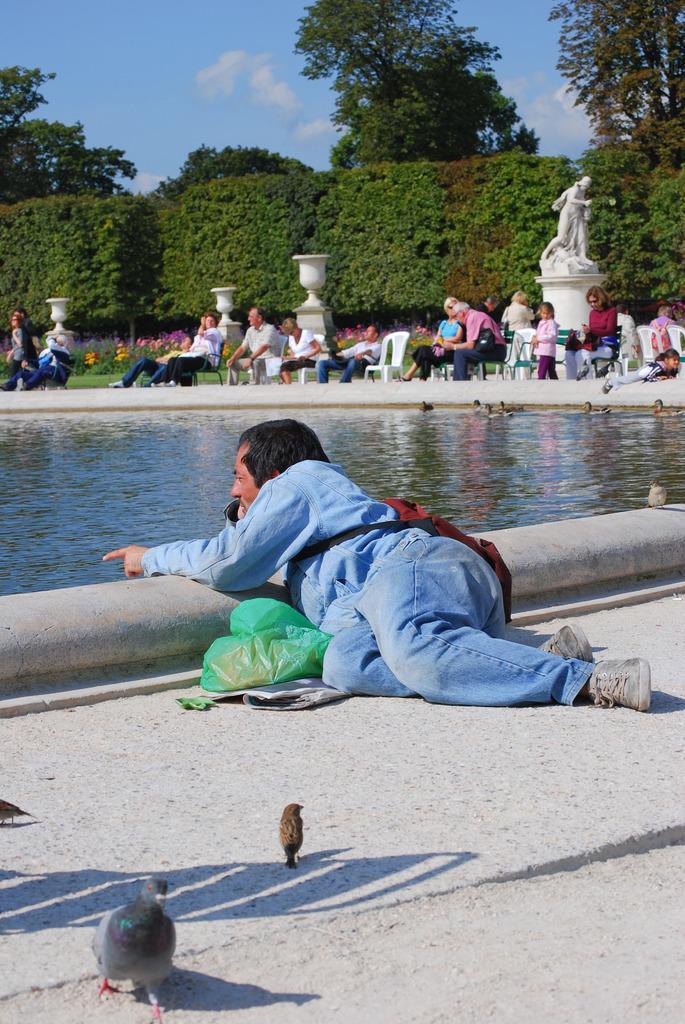Can you describe this image briefly? In this image we can see a person lying on the ground. Near to him there is a packet. Also there are few birds on the ground. In the back there is water. There are many people sitting. There is a statue on a pedestal. In the background there are bushes, trees. Also there is sky with clouds. 